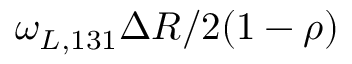<formula> <loc_0><loc_0><loc_500><loc_500>\omega _ { L , 1 3 1 } \Delta R / 2 ( 1 - \rho )</formula> 